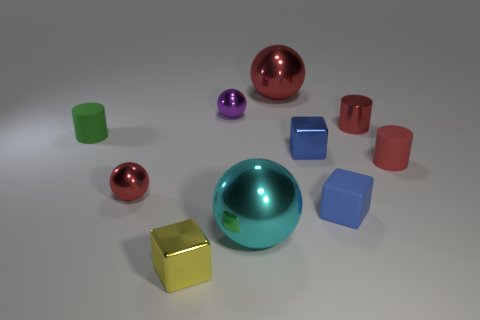What number of rubber cylinders are there?
Give a very brief answer. 2. There is a green object; is it the same size as the metal cube that is behind the big cyan metallic thing?
Your answer should be very brief. Yes. There is a thing that is left of the red ball that is in front of the red matte cylinder; what is its material?
Ensure brevity in your answer.  Rubber. There is a metallic cube on the right side of the large metallic thing behind the tiny sphere behind the tiny green rubber cylinder; what size is it?
Give a very brief answer. Small. Does the small red rubber thing have the same shape as the green rubber thing to the left of the tiny red matte thing?
Make the answer very short. Yes. What material is the small red sphere?
Keep it short and to the point. Metal. What number of metallic objects are green cylinders or tiny cubes?
Ensure brevity in your answer.  2. Are there fewer large red objects in front of the small yellow thing than small balls in front of the red matte thing?
Offer a terse response. Yes. There is a matte thing that is on the right side of the tiny red cylinder that is behind the green matte object; are there any small rubber cylinders that are right of it?
Ensure brevity in your answer.  No. There is another small cylinder that is the same color as the metal cylinder; what is its material?
Your answer should be compact. Rubber. 